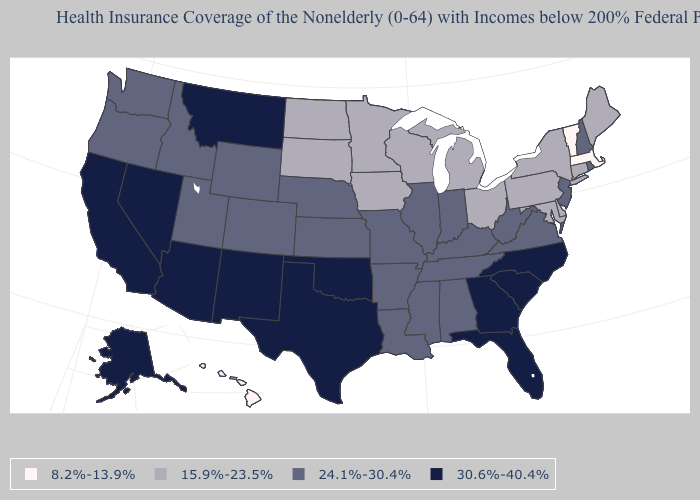What is the highest value in the USA?
Quick response, please. 30.6%-40.4%. Name the states that have a value in the range 15.9%-23.5%?
Short answer required. Connecticut, Delaware, Iowa, Maine, Maryland, Michigan, Minnesota, New York, North Dakota, Ohio, Pennsylvania, South Dakota, Wisconsin. What is the lowest value in the USA?
Write a very short answer. 8.2%-13.9%. Is the legend a continuous bar?
Be succinct. No. Does the map have missing data?
Quick response, please. No. Does the map have missing data?
Keep it brief. No. Name the states that have a value in the range 30.6%-40.4%?
Be succinct. Alaska, Arizona, California, Florida, Georgia, Montana, Nevada, New Mexico, North Carolina, Oklahoma, South Carolina, Texas. Is the legend a continuous bar?
Give a very brief answer. No. Which states have the highest value in the USA?
Keep it brief. Alaska, Arizona, California, Florida, Georgia, Montana, Nevada, New Mexico, North Carolina, Oklahoma, South Carolina, Texas. What is the lowest value in states that border Texas?
Be succinct. 24.1%-30.4%. Name the states that have a value in the range 24.1%-30.4%?
Write a very short answer. Alabama, Arkansas, Colorado, Idaho, Illinois, Indiana, Kansas, Kentucky, Louisiana, Mississippi, Missouri, Nebraska, New Hampshire, New Jersey, Oregon, Rhode Island, Tennessee, Utah, Virginia, Washington, West Virginia, Wyoming. Name the states that have a value in the range 15.9%-23.5%?
Be succinct. Connecticut, Delaware, Iowa, Maine, Maryland, Michigan, Minnesota, New York, North Dakota, Ohio, Pennsylvania, South Dakota, Wisconsin. Does Nebraska have a lower value than Montana?
Quick response, please. Yes. What is the value of Tennessee?
Keep it brief. 24.1%-30.4%. 